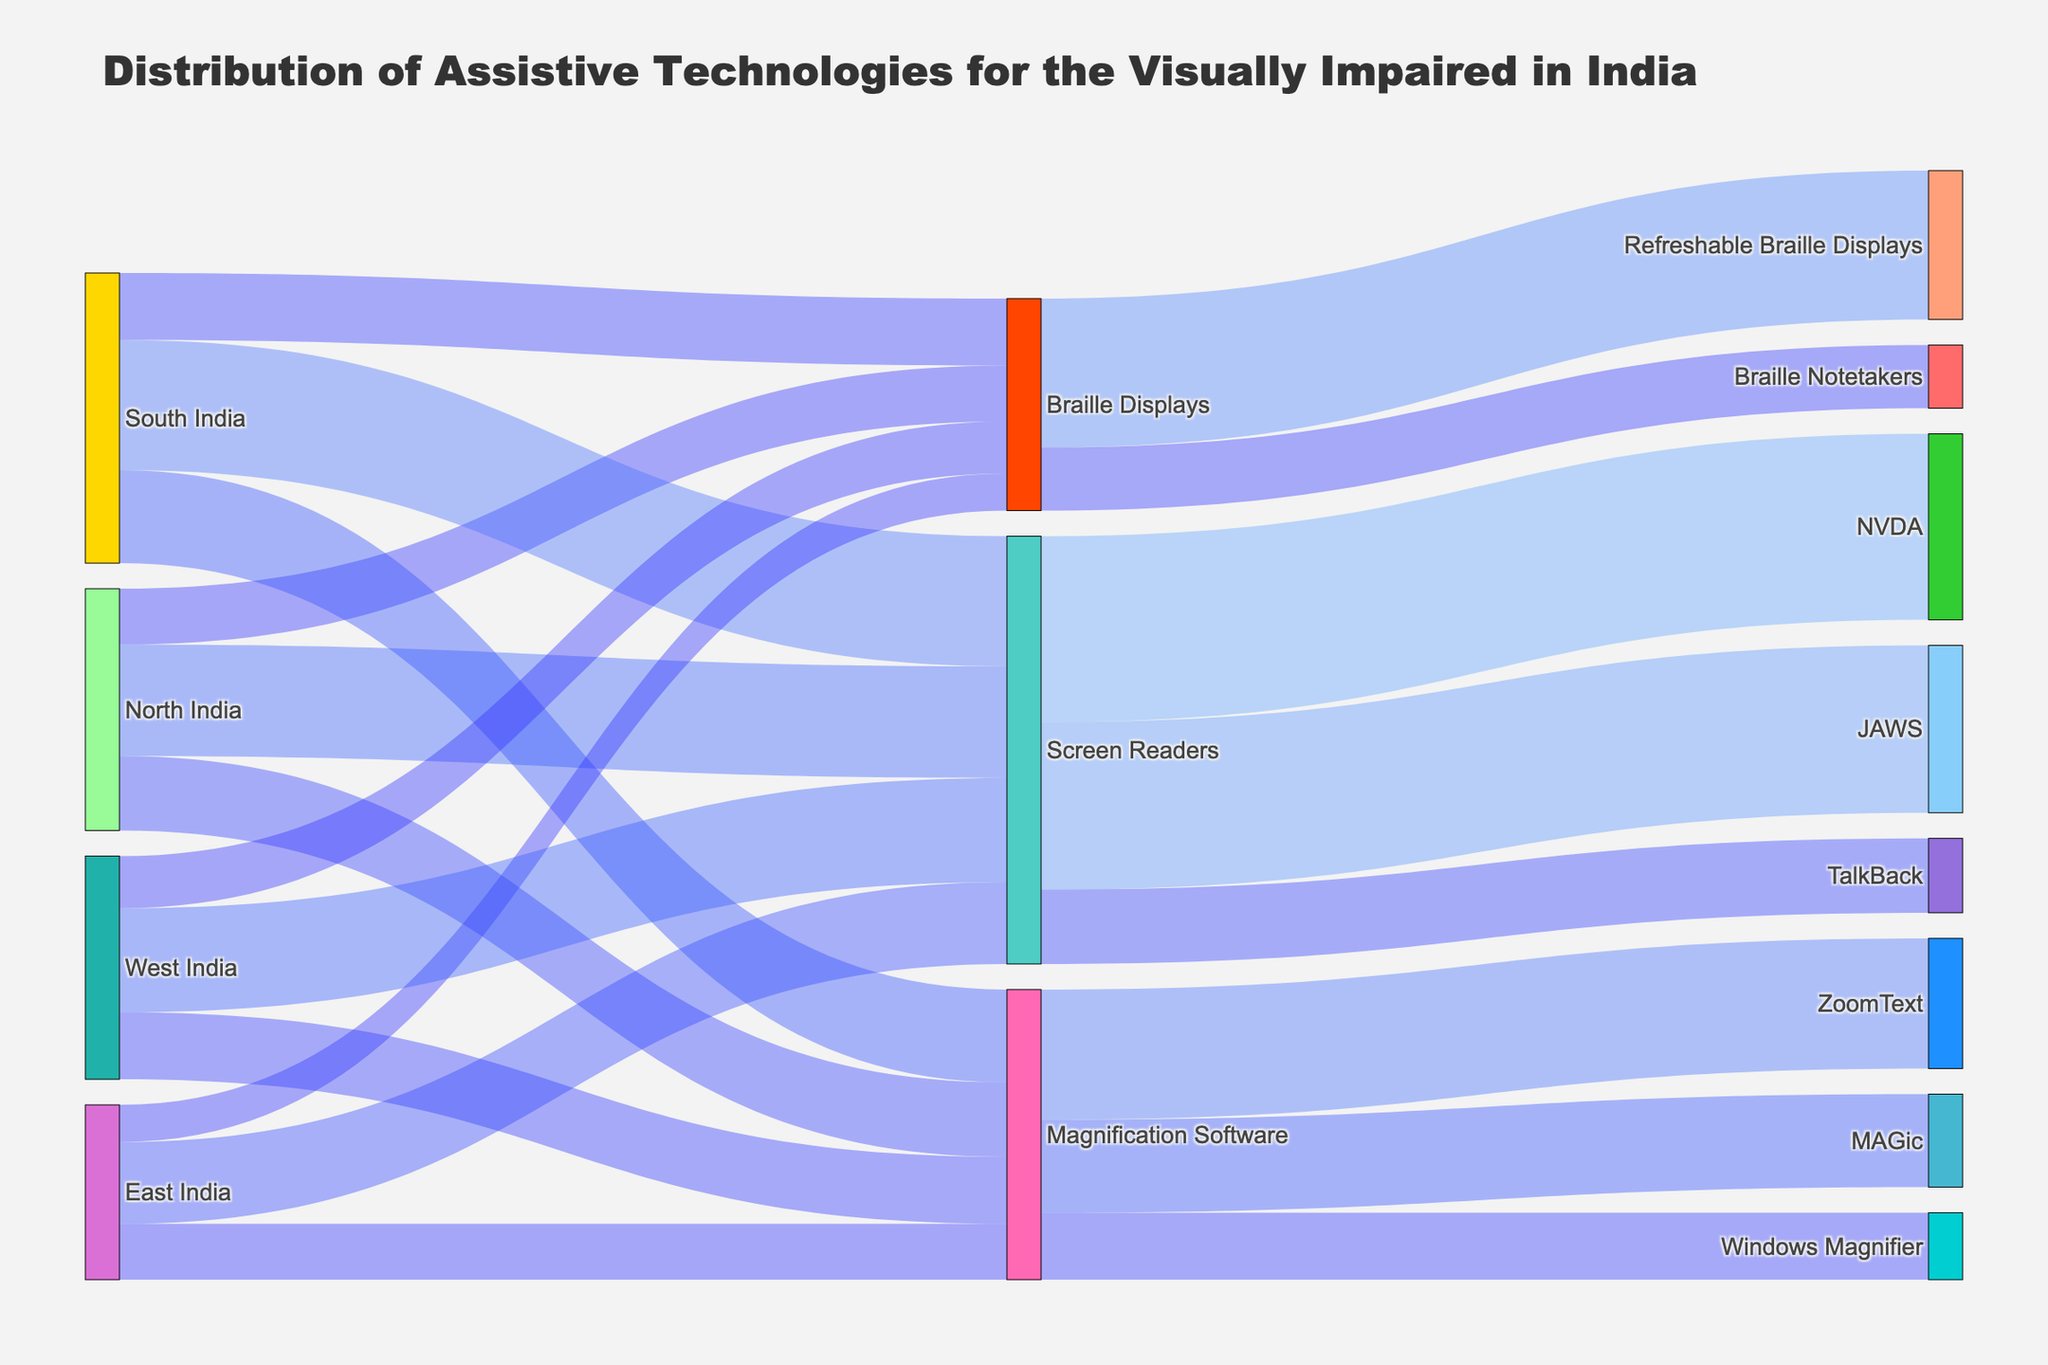What is the title of the figure? The title of the figure is displayed at the top and summarizes what the diagram is about.
Answer: Distribution of Assistive Technologies for the Visually Impaired in India Which region has the highest distribution of Screen Readers? To determine which region has the highest distribution of Screen Readers, we need to compare the values for Screen Readers in each region: North India (30000), South India (35000), East India (22000), and West India (28000).
Answer: South India How many Screen Readers are distributed in total across all regions? To find the total number of Screen Readers distributed, sum the values from all regions: 30000 (North) + 35000 (South) + 22000 (East) + 28000 (West).
Answer: 115000 Between JAWS and NVDA, which screen reader has been distributed more? To compare JAWS and NVDA, refer to their corresponding values: JAWS (45000) and NVDA (50000).
Answer: NVDA What is the distribution value of TalkBack Screen Readers? The figure shows the specific values for each type of screen reader distributed. We need to find the value of TalkBack.
Answer: 20000 Which type of Magnification Software has the highest distribution? To determine which type of Magnification Software has the highest distribution, compare the values of ZoomText (35000), MAGic (25000), and Windows Magnifier (18000).
Answer: ZoomText How does the distribution of Braille Displays in North India compare to South India? Compare the values of Braille Displays in both regions: 15000 in North India and 18000 in South India.
Answer: South India has more Braille Displays distributed than North India What is the combined distribution of Refreshable Braille Displays and Braille Notetakers? To find the combined distribution, sum the values of Refreshable Braille Displays (40000) and Braille Notetakers (17000).
Answer: 57000 Which region has the smallest total distribution of assistive technologies? To find the region with the smallest total distribution, sum the values for each region and compare: North India (30000 + 15000 + 20000), South India (35000 + 18000 + 25000), East India (22000 + 10000 + 15000), and West India (28000 + 14000 + 18000). North India: 65000, South India: 78000, East India: 47000, West India: 60000.
Answer: East India What proportion of Magnification Software is ZoomText? To find the proportion of ZoomText, divide its value by the total Magnification Software distribution and convert it to percentage: 35000 / (35000 + 25000 + 18000) ≈ 56%.
Answer: 56% 